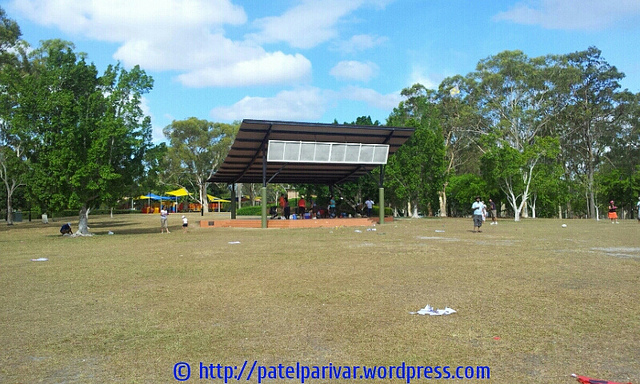Identify and read out the text in this image. http;//patelparivar.wordpress.com 